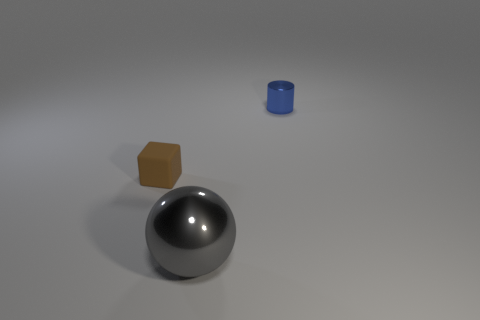How many things are either small metallic cylinders or metal objects?
Provide a short and direct response. 2. Is the number of small brown rubber blocks less than the number of small red rubber cylinders?
Offer a very short reply. No. What is the size of the blue thing that is the same material as the sphere?
Your response must be concise. Small. What is the size of the sphere?
Give a very brief answer. Large. There is a gray shiny object; what shape is it?
Offer a very short reply. Sphere. Do the metal thing that is on the right side of the sphere and the big object have the same color?
Your answer should be compact. No. Are there any other things that have the same material as the cube?
Provide a short and direct response. No. Is there a blue cylinder to the right of the tiny object left of the shiny object in front of the tiny brown cube?
Ensure brevity in your answer.  Yes. What material is the tiny object right of the large gray sphere?
Provide a succinct answer. Metal. What number of big objects are gray rubber cubes or metal cylinders?
Offer a very short reply. 0. 